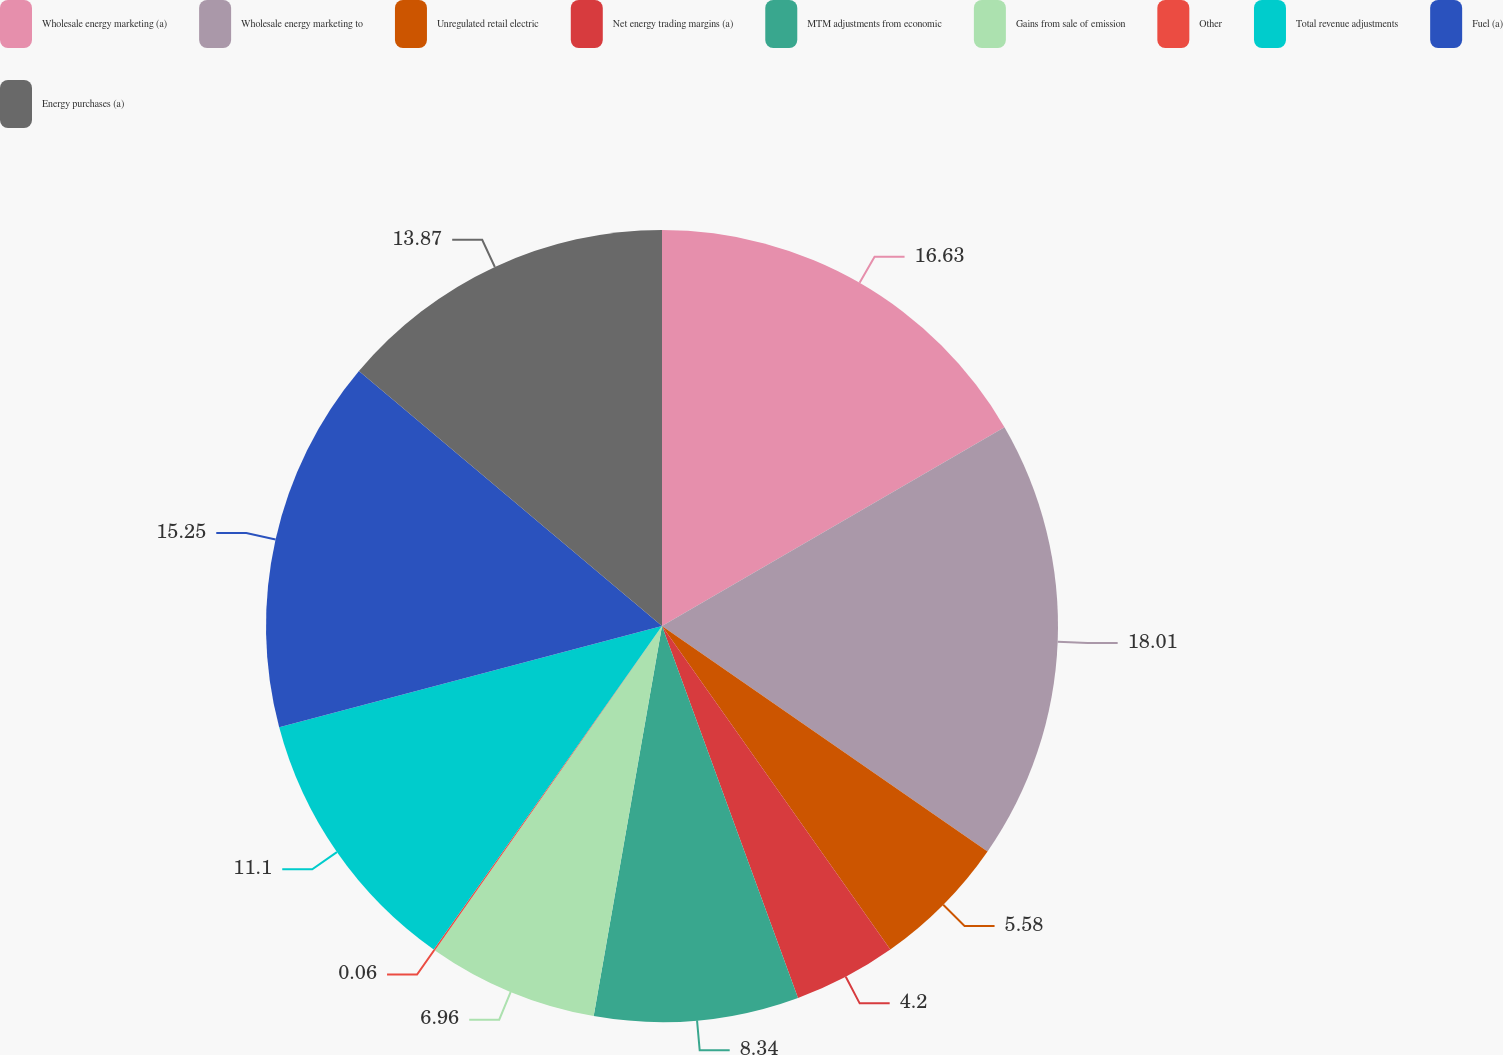<chart> <loc_0><loc_0><loc_500><loc_500><pie_chart><fcel>Wholesale energy marketing (a)<fcel>Wholesale energy marketing to<fcel>Unregulated retail electric<fcel>Net energy trading margins (a)<fcel>MTM adjustments from economic<fcel>Gains from sale of emission<fcel>Other<fcel>Total revenue adjustments<fcel>Fuel (a)<fcel>Energy purchases (a)<nl><fcel>16.63%<fcel>18.01%<fcel>5.58%<fcel>4.2%<fcel>8.34%<fcel>6.96%<fcel>0.06%<fcel>11.1%<fcel>15.25%<fcel>13.87%<nl></chart> 